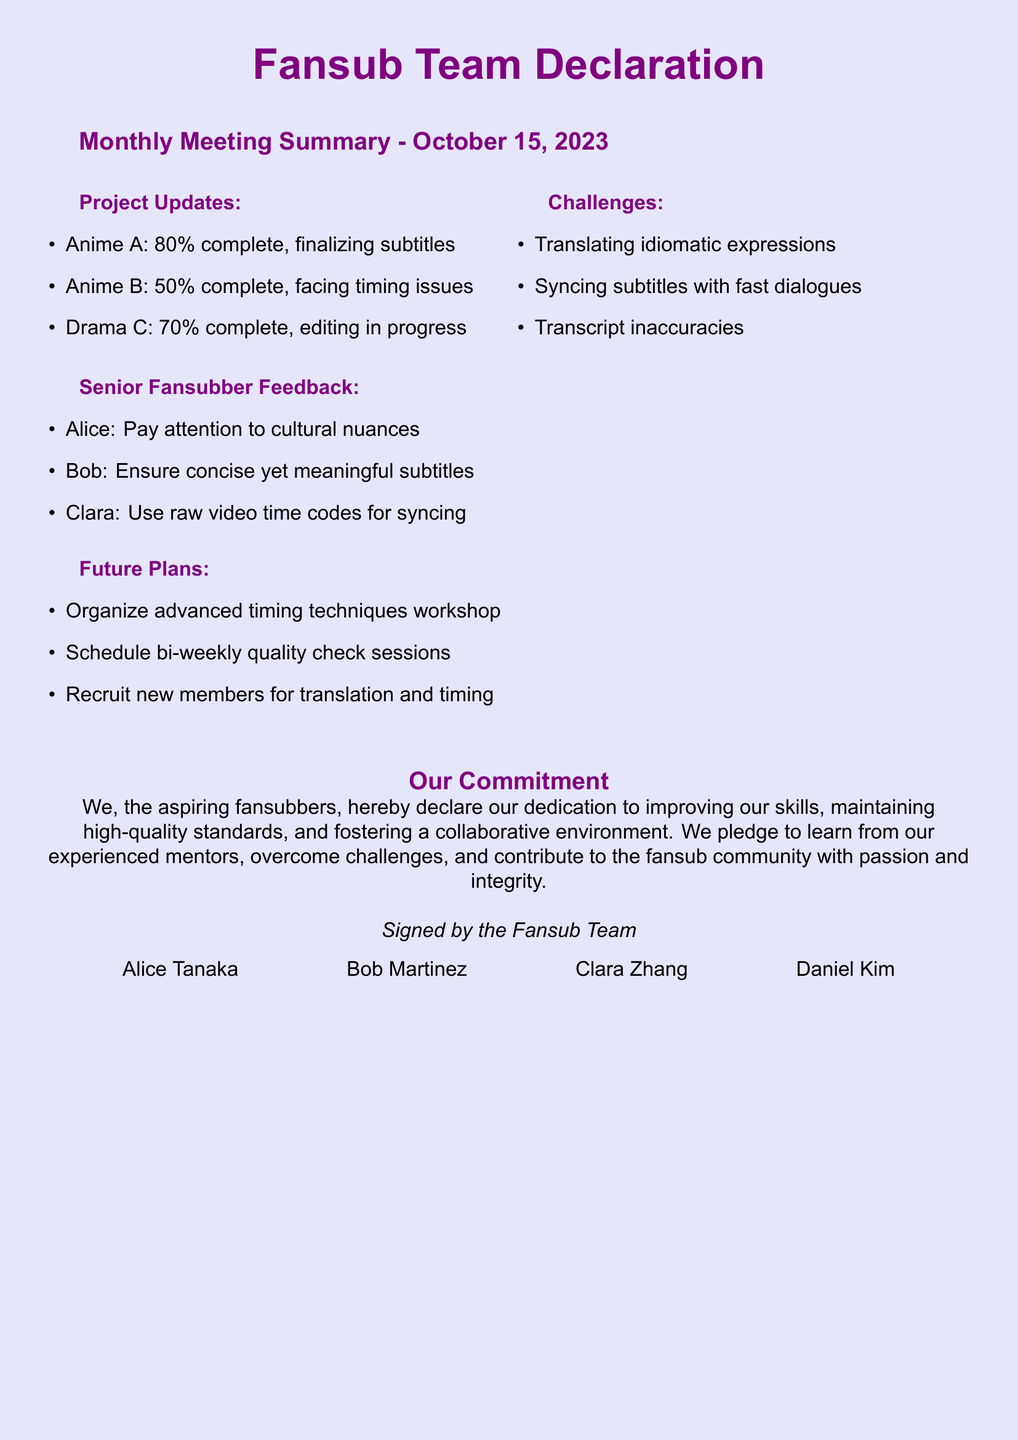What is the meeting date? The meeting date is explicitly mentioned in the summary section of the document.
Answer: October 15, 2023 What percentage is Anime A complete? The document lists progress percentages for each project, and for Anime A it states 80%.
Answer: 80% Who provided feedback on cultural nuances? The feedback section credits specific individuals with comments, and Alice is noted for cultural nuances.
Answer: Alice What are the two main challenges faced by the team? The document lists multiple challenges, and two of them that stand out are translating idiomatic expressions and syncing subtitles.
Answer: Translating idiomatic expressions, Syncing subtitles with fast dialogues What future plan involves skill development? The future plans section includes an initiative designed to enhance skills, specifically a workshop.
Answer: Organize advanced timing techniques workshop What is the total completion percentage for Drama C? The document states the completion status of various projects, with Drama C indicated as 70% complete.
Answer: 70% Which senior fansubber emphasized concise subtitles? The feedback from senior fansubbers includes specific names linked to their comments, with Bob noted for concise subtitles.
Answer: Bob How many general future plans are listed? The future plans section outlines several items, which can be counted to obtain the total.
Answer: Three What does the declaration signify about the fansub team? The commitment section highlights the team's dedication to improvement and quality standards.
Answer: Our dedication to improving our skills 